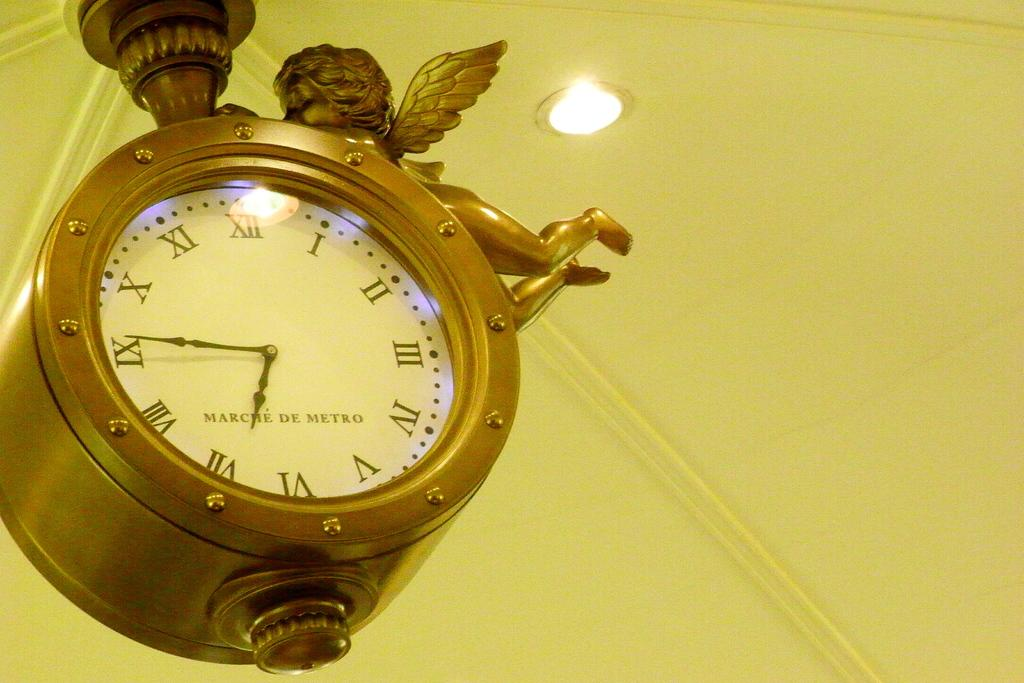<image>
Provide a brief description of the given image. Brown clock by Marche De Metro is hanging from the ceiling. 